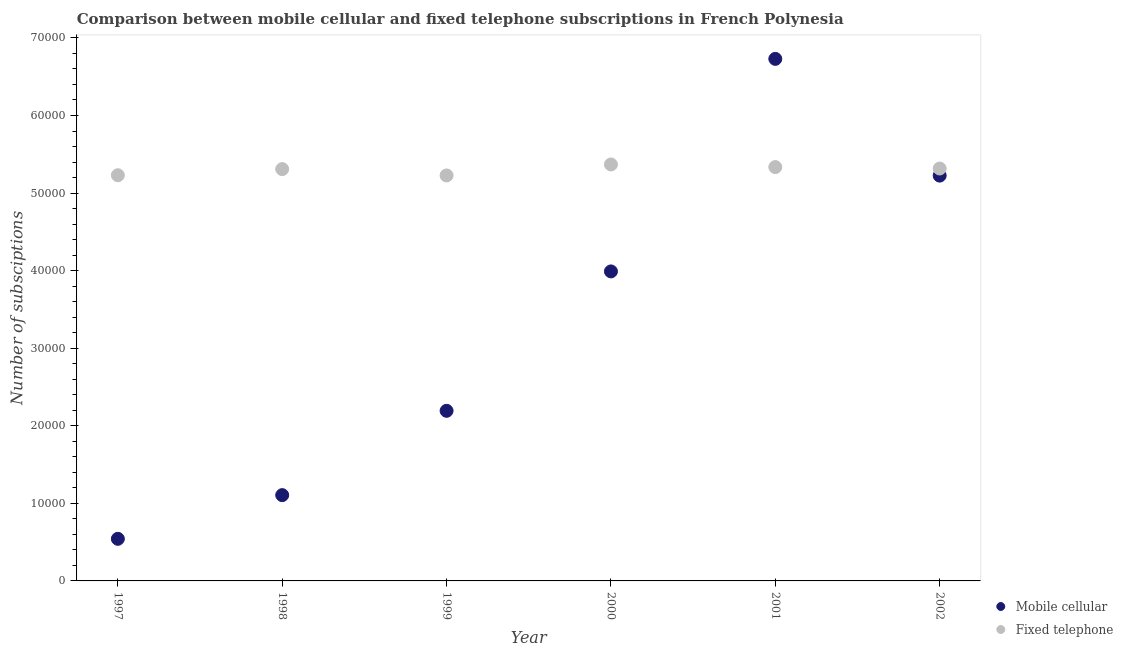How many different coloured dotlines are there?
Give a very brief answer. 2. Is the number of dotlines equal to the number of legend labels?
Provide a short and direct response. Yes. What is the number of mobile cellular subscriptions in 1997?
Provide a succinct answer. 5427. Across all years, what is the maximum number of fixed telephone subscriptions?
Your answer should be very brief. 5.37e+04. Across all years, what is the minimum number of fixed telephone subscriptions?
Provide a short and direct response. 5.23e+04. In which year was the number of mobile cellular subscriptions minimum?
Offer a very short reply. 1997. What is the total number of mobile cellular subscriptions in the graph?
Provide a succinct answer. 1.98e+05. What is the difference between the number of mobile cellular subscriptions in 2000 and that in 2001?
Your answer should be very brief. -2.74e+04. What is the difference between the number of fixed telephone subscriptions in 1997 and the number of mobile cellular subscriptions in 1999?
Make the answer very short. 3.04e+04. What is the average number of fixed telephone subscriptions per year?
Keep it short and to the point. 5.30e+04. In the year 1999, what is the difference between the number of mobile cellular subscriptions and number of fixed telephone subscriptions?
Your answer should be very brief. -3.03e+04. What is the ratio of the number of fixed telephone subscriptions in 1998 to that in 2000?
Ensure brevity in your answer.  0.99. Is the difference between the number of mobile cellular subscriptions in 1998 and 2002 greater than the difference between the number of fixed telephone subscriptions in 1998 and 2002?
Give a very brief answer. No. What is the difference between the highest and the second highest number of fixed telephone subscriptions?
Ensure brevity in your answer.  339. What is the difference between the highest and the lowest number of fixed telephone subscriptions?
Your response must be concise. 1417. In how many years, is the number of mobile cellular subscriptions greater than the average number of mobile cellular subscriptions taken over all years?
Your answer should be very brief. 3. Does the number of fixed telephone subscriptions monotonically increase over the years?
Keep it short and to the point. No. Is the number of mobile cellular subscriptions strictly greater than the number of fixed telephone subscriptions over the years?
Ensure brevity in your answer.  No. Is the number of fixed telephone subscriptions strictly less than the number of mobile cellular subscriptions over the years?
Give a very brief answer. No. How many years are there in the graph?
Provide a short and direct response. 6. Does the graph contain any zero values?
Your answer should be compact. No. Where does the legend appear in the graph?
Make the answer very short. Bottom right. How are the legend labels stacked?
Provide a short and direct response. Vertical. What is the title of the graph?
Offer a terse response. Comparison between mobile cellular and fixed telephone subscriptions in French Polynesia. Does "Secondary Education" appear as one of the legend labels in the graph?
Offer a terse response. No. What is the label or title of the Y-axis?
Your response must be concise. Number of subsciptions. What is the Number of subsciptions of Mobile cellular in 1997?
Your response must be concise. 5427. What is the Number of subsciptions of Fixed telephone in 1997?
Offer a very short reply. 5.23e+04. What is the Number of subsciptions in Mobile cellular in 1998?
Provide a succinct answer. 1.11e+04. What is the Number of subsciptions of Fixed telephone in 1998?
Offer a terse response. 5.31e+04. What is the Number of subsciptions of Mobile cellular in 1999?
Provide a short and direct response. 2.19e+04. What is the Number of subsciptions in Fixed telephone in 1999?
Give a very brief answer. 5.23e+04. What is the Number of subsciptions in Mobile cellular in 2000?
Give a very brief answer. 3.99e+04. What is the Number of subsciptions in Fixed telephone in 2000?
Keep it short and to the point. 5.37e+04. What is the Number of subsciptions in Mobile cellular in 2001?
Ensure brevity in your answer.  6.73e+04. What is the Number of subsciptions in Fixed telephone in 2001?
Your response must be concise. 5.34e+04. What is the Number of subsciptions in Mobile cellular in 2002?
Provide a succinct answer. 5.22e+04. What is the Number of subsciptions in Fixed telephone in 2002?
Offer a terse response. 5.32e+04. Across all years, what is the maximum Number of subsciptions in Mobile cellular?
Ensure brevity in your answer.  6.73e+04. Across all years, what is the maximum Number of subsciptions of Fixed telephone?
Offer a very short reply. 5.37e+04. Across all years, what is the minimum Number of subsciptions in Mobile cellular?
Keep it short and to the point. 5427. Across all years, what is the minimum Number of subsciptions of Fixed telephone?
Keep it short and to the point. 5.23e+04. What is the total Number of subsciptions of Mobile cellular in the graph?
Offer a terse response. 1.98e+05. What is the total Number of subsciptions in Fixed telephone in the graph?
Provide a short and direct response. 3.18e+05. What is the difference between the Number of subsciptions of Mobile cellular in 1997 and that in 1998?
Offer a very short reply. -5633. What is the difference between the Number of subsciptions in Fixed telephone in 1997 and that in 1998?
Your answer should be very brief. -792. What is the difference between the Number of subsciptions of Mobile cellular in 1997 and that in 1999?
Give a very brief answer. -1.65e+04. What is the difference between the Number of subsciptions in Fixed telephone in 1997 and that in 1999?
Your response must be concise. 25. What is the difference between the Number of subsciptions of Mobile cellular in 1997 and that in 2000?
Make the answer very short. -3.45e+04. What is the difference between the Number of subsciptions of Fixed telephone in 1997 and that in 2000?
Offer a very short reply. -1392. What is the difference between the Number of subsciptions in Mobile cellular in 1997 and that in 2001?
Make the answer very short. -6.19e+04. What is the difference between the Number of subsciptions in Fixed telephone in 1997 and that in 2001?
Provide a succinct answer. -1053. What is the difference between the Number of subsciptions of Mobile cellular in 1997 and that in 2002?
Offer a very short reply. -4.68e+04. What is the difference between the Number of subsciptions in Fixed telephone in 1997 and that in 2002?
Keep it short and to the point. -869. What is the difference between the Number of subsciptions of Mobile cellular in 1998 and that in 1999?
Your answer should be compact. -1.09e+04. What is the difference between the Number of subsciptions of Fixed telephone in 1998 and that in 1999?
Offer a terse response. 817. What is the difference between the Number of subsciptions of Mobile cellular in 1998 and that in 2000?
Make the answer very short. -2.88e+04. What is the difference between the Number of subsciptions of Fixed telephone in 1998 and that in 2000?
Your response must be concise. -600. What is the difference between the Number of subsciptions of Mobile cellular in 1998 and that in 2001?
Keep it short and to the point. -5.62e+04. What is the difference between the Number of subsciptions in Fixed telephone in 1998 and that in 2001?
Offer a very short reply. -261. What is the difference between the Number of subsciptions in Mobile cellular in 1998 and that in 2002?
Your response must be concise. -4.12e+04. What is the difference between the Number of subsciptions of Fixed telephone in 1998 and that in 2002?
Provide a succinct answer. -77. What is the difference between the Number of subsciptions in Mobile cellular in 1999 and that in 2000?
Your answer should be compact. -1.80e+04. What is the difference between the Number of subsciptions of Fixed telephone in 1999 and that in 2000?
Provide a short and direct response. -1417. What is the difference between the Number of subsciptions in Mobile cellular in 1999 and that in 2001?
Keep it short and to the point. -4.54e+04. What is the difference between the Number of subsciptions of Fixed telephone in 1999 and that in 2001?
Provide a succinct answer. -1078. What is the difference between the Number of subsciptions of Mobile cellular in 1999 and that in 2002?
Offer a very short reply. -3.03e+04. What is the difference between the Number of subsciptions of Fixed telephone in 1999 and that in 2002?
Your answer should be compact. -894. What is the difference between the Number of subsciptions of Mobile cellular in 2000 and that in 2001?
Offer a very short reply. -2.74e+04. What is the difference between the Number of subsciptions of Fixed telephone in 2000 and that in 2001?
Ensure brevity in your answer.  339. What is the difference between the Number of subsciptions of Mobile cellular in 2000 and that in 2002?
Your answer should be compact. -1.24e+04. What is the difference between the Number of subsciptions of Fixed telephone in 2000 and that in 2002?
Your response must be concise. 523. What is the difference between the Number of subsciptions of Mobile cellular in 2001 and that in 2002?
Offer a very short reply. 1.50e+04. What is the difference between the Number of subsciptions in Fixed telephone in 2001 and that in 2002?
Ensure brevity in your answer.  184. What is the difference between the Number of subsciptions in Mobile cellular in 1997 and the Number of subsciptions in Fixed telephone in 1998?
Give a very brief answer. -4.77e+04. What is the difference between the Number of subsciptions of Mobile cellular in 1997 and the Number of subsciptions of Fixed telephone in 1999?
Ensure brevity in your answer.  -4.68e+04. What is the difference between the Number of subsciptions of Mobile cellular in 1997 and the Number of subsciptions of Fixed telephone in 2000?
Provide a short and direct response. -4.83e+04. What is the difference between the Number of subsciptions in Mobile cellular in 1997 and the Number of subsciptions in Fixed telephone in 2001?
Your response must be concise. -4.79e+04. What is the difference between the Number of subsciptions of Mobile cellular in 1997 and the Number of subsciptions of Fixed telephone in 2002?
Offer a terse response. -4.77e+04. What is the difference between the Number of subsciptions of Mobile cellular in 1998 and the Number of subsciptions of Fixed telephone in 1999?
Ensure brevity in your answer.  -4.12e+04. What is the difference between the Number of subsciptions of Mobile cellular in 1998 and the Number of subsciptions of Fixed telephone in 2000?
Provide a short and direct response. -4.26e+04. What is the difference between the Number of subsciptions in Mobile cellular in 1998 and the Number of subsciptions in Fixed telephone in 2001?
Provide a short and direct response. -4.23e+04. What is the difference between the Number of subsciptions of Mobile cellular in 1998 and the Number of subsciptions of Fixed telephone in 2002?
Ensure brevity in your answer.  -4.21e+04. What is the difference between the Number of subsciptions of Mobile cellular in 1999 and the Number of subsciptions of Fixed telephone in 2000?
Offer a very short reply. -3.18e+04. What is the difference between the Number of subsciptions in Mobile cellular in 1999 and the Number of subsciptions in Fixed telephone in 2001?
Your answer should be compact. -3.14e+04. What is the difference between the Number of subsciptions in Mobile cellular in 1999 and the Number of subsciptions in Fixed telephone in 2002?
Give a very brief answer. -3.12e+04. What is the difference between the Number of subsciptions in Mobile cellular in 2000 and the Number of subsciptions in Fixed telephone in 2001?
Make the answer very short. -1.34e+04. What is the difference between the Number of subsciptions in Mobile cellular in 2000 and the Number of subsciptions in Fixed telephone in 2002?
Ensure brevity in your answer.  -1.33e+04. What is the difference between the Number of subsciptions in Mobile cellular in 2001 and the Number of subsciptions in Fixed telephone in 2002?
Make the answer very short. 1.41e+04. What is the average Number of subsciptions of Mobile cellular per year?
Offer a very short reply. 3.30e+04. What is the average Number of subsciptions in Fixed telephone per year?
Your answer should be very brief. 5.30e+04. In the year 1997, what is the difference between the Number of subsciptions of Mobile cellular and Number of subsciptions of Fixed telephone?
Your answer should be compact. -4.69e+04. In the year 1998, what is the difference between the Number of subsciptions of Mobile cellular and Number of subsciptions of Fixed telephone?
Give a very brief answer. -4.20e+04. In the year 1999, what is the difference between the Number of subsciptions in Mobile cellular and Number of subsciptions in Fixed telephone?
Your answer should be very brief. -3.03e+04. In the year 2000, what is the difference between the Number of subsciptions in Mobile cellular and Number of subsciptions in Fixed telephone?
Offer a very short reply. -1.38e+04. In the year 2001, what is the difference between the Number of subsciptions of Mobile cellular and Number of subsciptions of Fixed telephone?
Your response must be concise. 1.40e+04. In the year 2002, what is the difference between the Number of subsciptions in Mobile cellular and Number of subsciptions in Fixed telephone?
Make the answer very short. -916. What is the ratio of the Number of subsciptions of Mobile cellular in 1997 to that in 1998?
Keep it short and to the point. 0.49. What is the ratio of the Number of subsciptions of Fixed telephone in 1997 to that in 1998?
Keep it short and to the point. 0.99. What is the ratio of the Number of subsciptions in Mobile cellular in 1997 to that in 1999?
Offer a terse response. 0.25. What is the ratio of the Number of subsciptions of Fixed telephone in 1997 to that in 1999?
Your answer should be compact. 1. What is the ratio of the Number of subsciptions of Mobile cellular in 1997 to that in 2000?
Your answer should be compact. 0.14. What is the ratio of the Number of subsciptions in Fixed telephone in 1997 to that in 2000?
Your answer should be very brief. 0.97. What is the ratio of the Number of subsciptions in Mobile cellular in 1997 to that in 2001?
Your response must be concise. 0.08. What is the ratio of the Number of subsciptions in Fixed telephone in 1997 to that in 2001?
Provide a succinct answer. 0.98. What is the ratio of the Number of subsciptions of Mobile cellular in 1997 to that in 2002?
Your answer should be compact. 0.1. What is the ratio of the Number of subsciptions of Fixed telephone in 1997 to that in 2002?
Your answer should be compact. 0.98. What is the ratio of the Number of subsciptions of Mobile cellular in 1998 to that in 1999?
Offer a terse response. 0.5. What is the ratio of the Number of subsciptions in Fixed telephone in 1998 to that in 1999?
Keep it short and to the point. 1.02. What is the ratio of the Number of subsciptions in Mobile cellular in 1998 to that in 2000?
Your response must be concise. 0.28. What is the ratio of the Number of subsciptions of Mobile cellular in 1998 to that in 2001?
Ensure brevity in your answer.  0.16. What is the ratio of the Number of subsciptions of Fixed telephone in 1998 to that in 2001?
Ensure brevity in your answer.  1. What is the ratio of the Number of subsciptions of Mobile cellular in 1998 to that in 2002?
Your answer should be very brief. 0.21. What is the ratio of the Number of subsciptions in Mobile cellular in 1999 to that in 2000?
Ensure brevity in your answer.  0.55. What is the ratio of the Number of subsciptions of Fixed telephone in 1999 to that in 2000?
Ensure brevity in your answer.  0.97. What is the ratio of the Number of subsciptions in Mobile cellular in 1999 to that in 2001?
Keep it short and to the point. 0.33. What is the ratio of the Number of subsciptions of Fixed telephone in 1999 to that in 2001?
Your answer should be very brief. 0.98. What is the ratio of the Number of subsciptions of Mobile cellular in 1999 to that in 2002?
Your answer should be compact. 0.42. What is the ratio of the Number of subsciptions of Fixed telephone in 1999 to that in 2002?
Offer a terse response. 0.98. What is the ratio of the Number of subsciptions in Mobile cellular in 2000 to that in 2001?
Give a very brief answer. 0.59. What is the ratio of the Number of subsciptions in Fixed telephone in 2000 to that in 2001?
Provide a short and direct response. 1.01. What is the ratio of the Number of subsciptions of Mobile cellular in 2000 to that in 2002?
Your answer should be very brief. 0.76. What is the ratio of the Number of subsciptions of Fixed telephone in 2000 to that in 2002?
Your answer should be very brief. 1.01. What is the ratio of the Number of subsciptions of Mobile cellular in 2001 to that in 2002?
Your answer should be very brief. 1.29. What is the difference between the highest and the second highest Number of subsciptions in Mobile cellular?
Offer a very short reply. 1.50e+04. What is the difference between the highest and the second highest Number of subsciptions in Fixed telephone?
Your response must be concise. 339. What is the difference between the highest and the lowest Number of subsciptions in Mobile cellular?
Offer a very short reply. 6.19e+04. What is the difference between the highest and the lowest Number of subsciptions in Fixed telephone?
Offer a very short reply. 1417. 